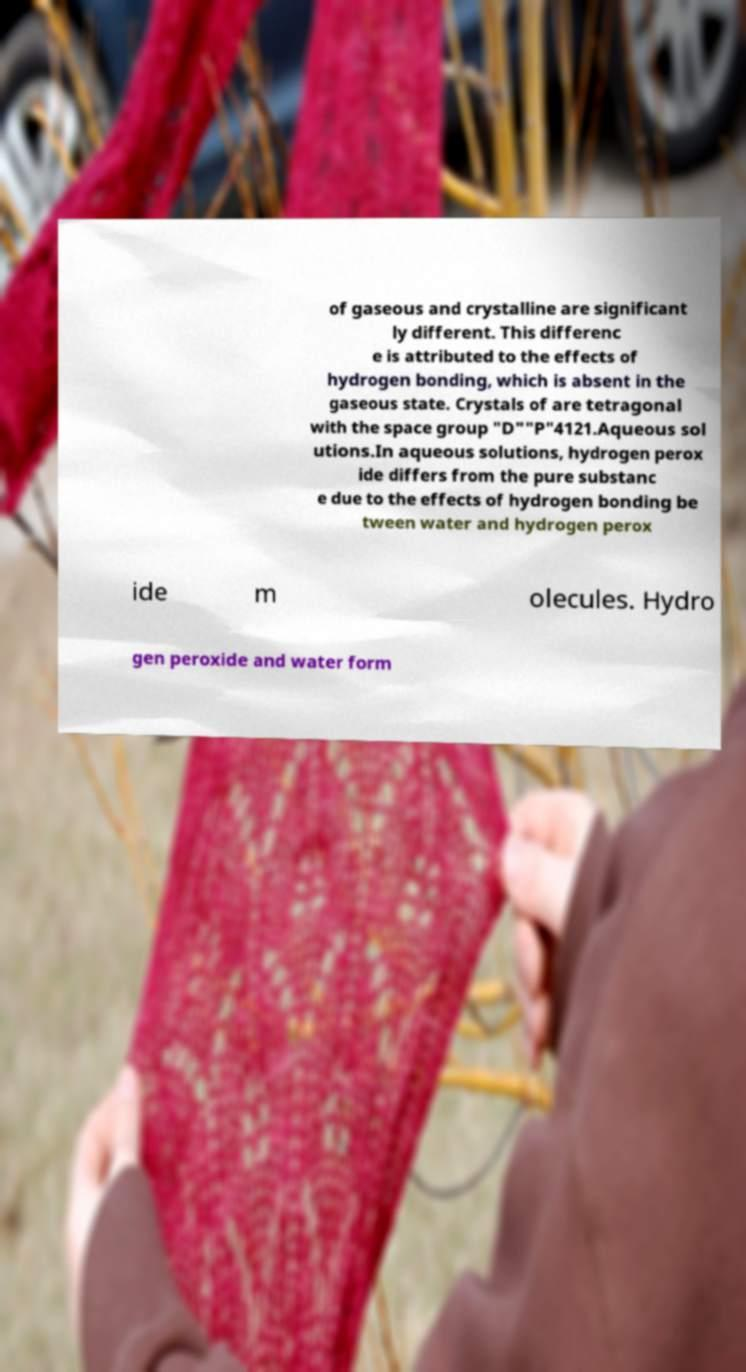Can you accurately transcribe the text from the provided image for me? of gaseous and crystalline are significant ly different. This differenc e is attributed to the effects of hydrogen bonding, which is absent in the gaseous state. Crystals of are tetragonal with the space group "D""P"4121.Aqueous sol utions.In aqueous solutions, hydrogen perox ide differs from the pure substanc e due to the effects of hydrogen bonding be tween water and hydrogen perox ide m olecules. Hydro gen peroxide and water form 